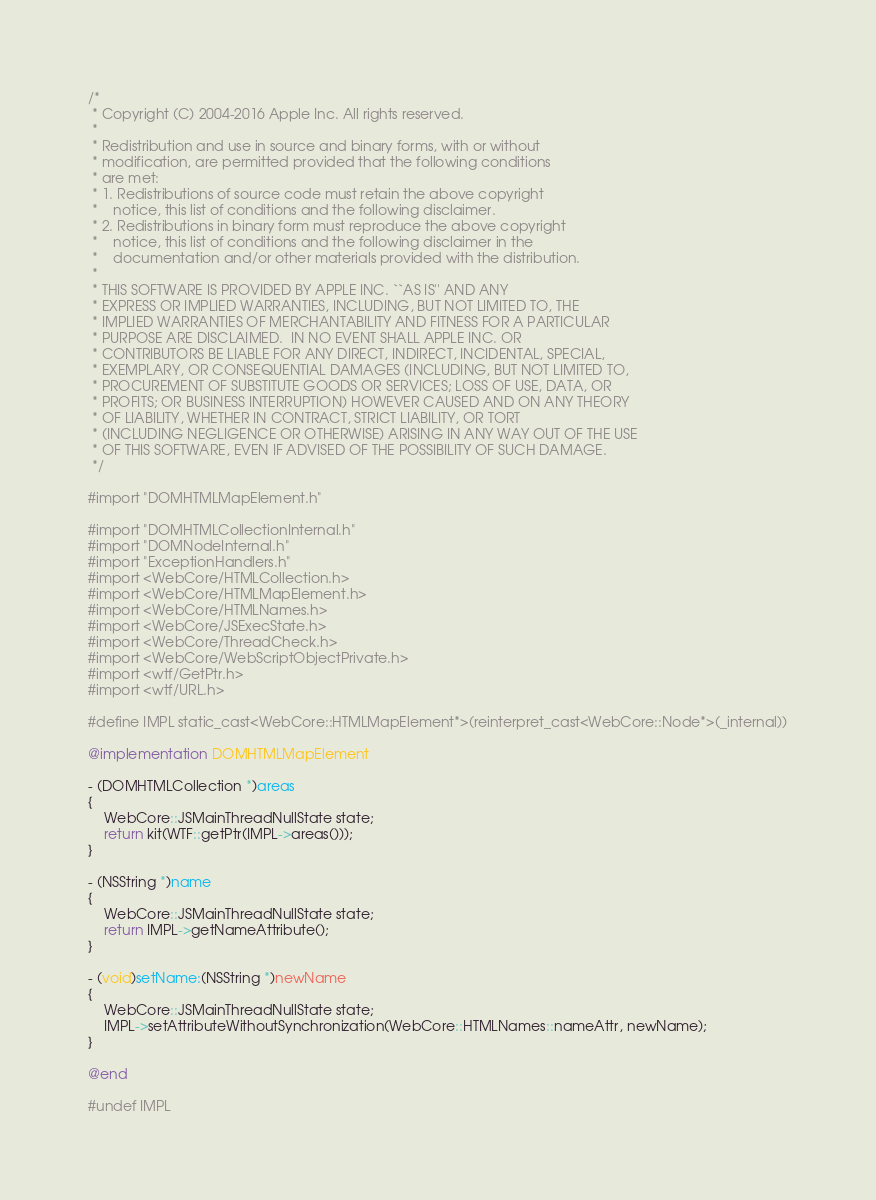<code> <loc_0><loc_0><loc_500><loc_500><_ObjectiveC_>/*
 * Copyright (C) 2004-2016 Apple Inc. All rights reserved.
 *
 * Redistribution and use in source and binary forms, with or without
 * modification, are permitted provided that the following conditions
 * are met:
 * 1. Redistributions of source code must retain the above copyright
 *    notice, this list of conditions and the following disclaimer.
 * 2. Redistributions in binary form must reproduce the above copyright
 *    notice, this list of conditions and the following disclaimer in the
 *    documentation and/or other materials provided with the distribution.
 *
 * THIS SOFTWARE IS PROVIDED BY APPLE INC. ``AS IS'' AND ANY
 * EXPRESS OR IMPLIED WARRANTIES, INCLUDING, BUT NOT LIMITED TO, THE
 * IMPLIED WARRANTIES OF MERCHANTABILITY AND FITNESS FOR A PARTICULAR
 * PURPOSE ARE DISCLAIMED.  IN NO EVENT SHALL APPLE INC. OR
 * CONTRIBUTORS BE LIABLE FOR ANY DIRECT, INDIRECT, INCIDENTAL, SPECIAL,
 * EXEMPLARY, OR CONSEQUENTIAL DAMAGES (INCLUDING, BUT NOT LIMITED TO,
 * PROCUREMENT OF SUBSTITUTE GOODS OR SERVICES; LOSS OF USE, DATA, OR
 * PROFITS; OR BUSINESS INTERRUPTION) HOWEVER CAUSED AND ON ANY THEORY
 * OF LIABILITY, WHETHER IN CONTRACT, STRICT LIABILITY, OR TORT
 * (INCLUDING NEGLIGENCE OR OTHERWISE) ARISING IN ANY WAY OUT OF THE USE
 * OF THIS SOFTWARE, EVEN IF ADVISED OF THE POSSIBILITY OF SUCH DAMAGE.
 */

#import "DOMHTMLMapElement.h"

#import "DOMHTMLCollectionInternal.h"
#import "DOMNodeInternal.h"
#import "ExceptionHandlers.h"
#import <WebCore/HTMLCollection.h>
#import <WebCore/HTMLMapElement.h>
#import <WebCore/HTMLNames.h>
#import <WebCore/JSExecState.h>
#import <WebCore/ThreadCheck.h>
#import <WebCore/WebScriptObjectPrivate.h>
#import <wtf/GetPtr.h>
#import <wtf/URL.h>

#define IMPL static_cast<WebCore::HTMLMapElement*>(reinterpret_cast<WebCore::Node*>(_internal))

@implementation DOMHTMLMapElement

- (DOMHTMLCollection *)areas
{
    WebCore::JSMainThreadNullState state;
    return kit(WTF::getPtr(IMPL->areas()));
}

- (NSString *)name
{
    WebCore::JSMainThreadNullState state;
    return IMPL->getNameAttribute();
}

- (void)setName:(NSString *)newName
{
    WebCore::JSMainThreadNullState state;
    IMPL->setAttributeWithoutSynchronization(WebCore::HTMLNames::nameAttr, newName);
}

@end

#undef IMPL
</code> 